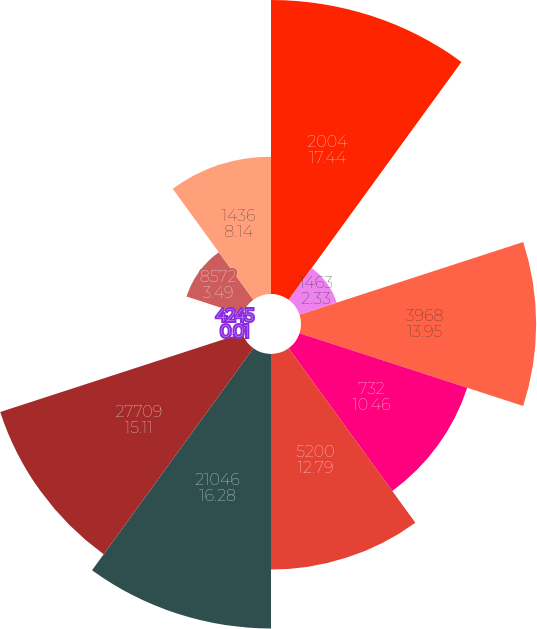<chart> <loc_0><loc_0><loc_500><loc_500><pie_chart><fcel>2004<fcel>1463<fcel>3968<fcel>732<fcel>5200<fcel>21046<fcel>27709<fcel>4245<fcel>8572<fcel>1436<nl><fcel>17.44%<fcel>2.33%<fcel>13.95%<fcel>10.46%<fcel>12.79%<fcel>16.28%<fcel>15.11%<fcel>0.01%<fcel>3.49%<fcel>8.14%<nl></chart> 